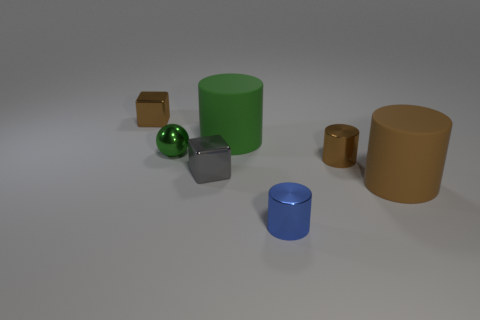Add 3 large green rubber objects. How many objects exist? 10 Subtract all cylinders. How many objects are left? 3 Subtract all big purple rubber objects. Subtract all tiny metal cylinders. How many objects are left? 5 Add 2 blue metallic cylinders. How many blue metallic cylinders are left? 3 Add 6 brown shiny cylinders. How many brown shiny cylinders exist? 7 Subtract 0 green cubes. How many objects are left? 7 